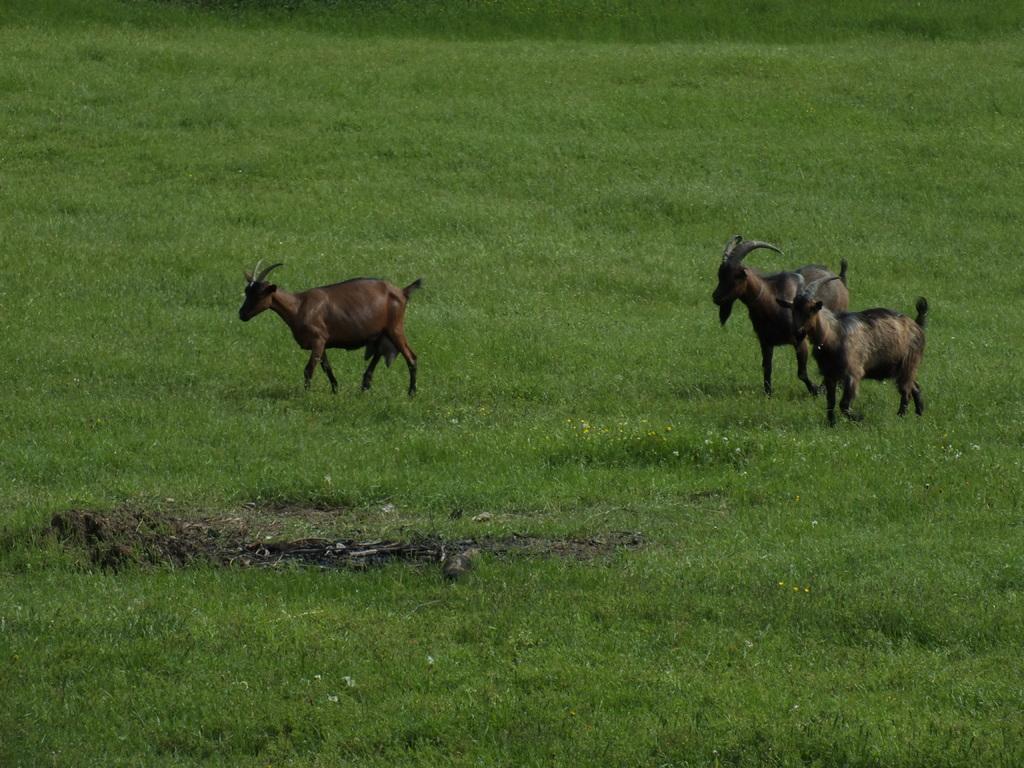Could you give a brief overview of what you see in this image? In this picture we can see there are three animals on the grass. 